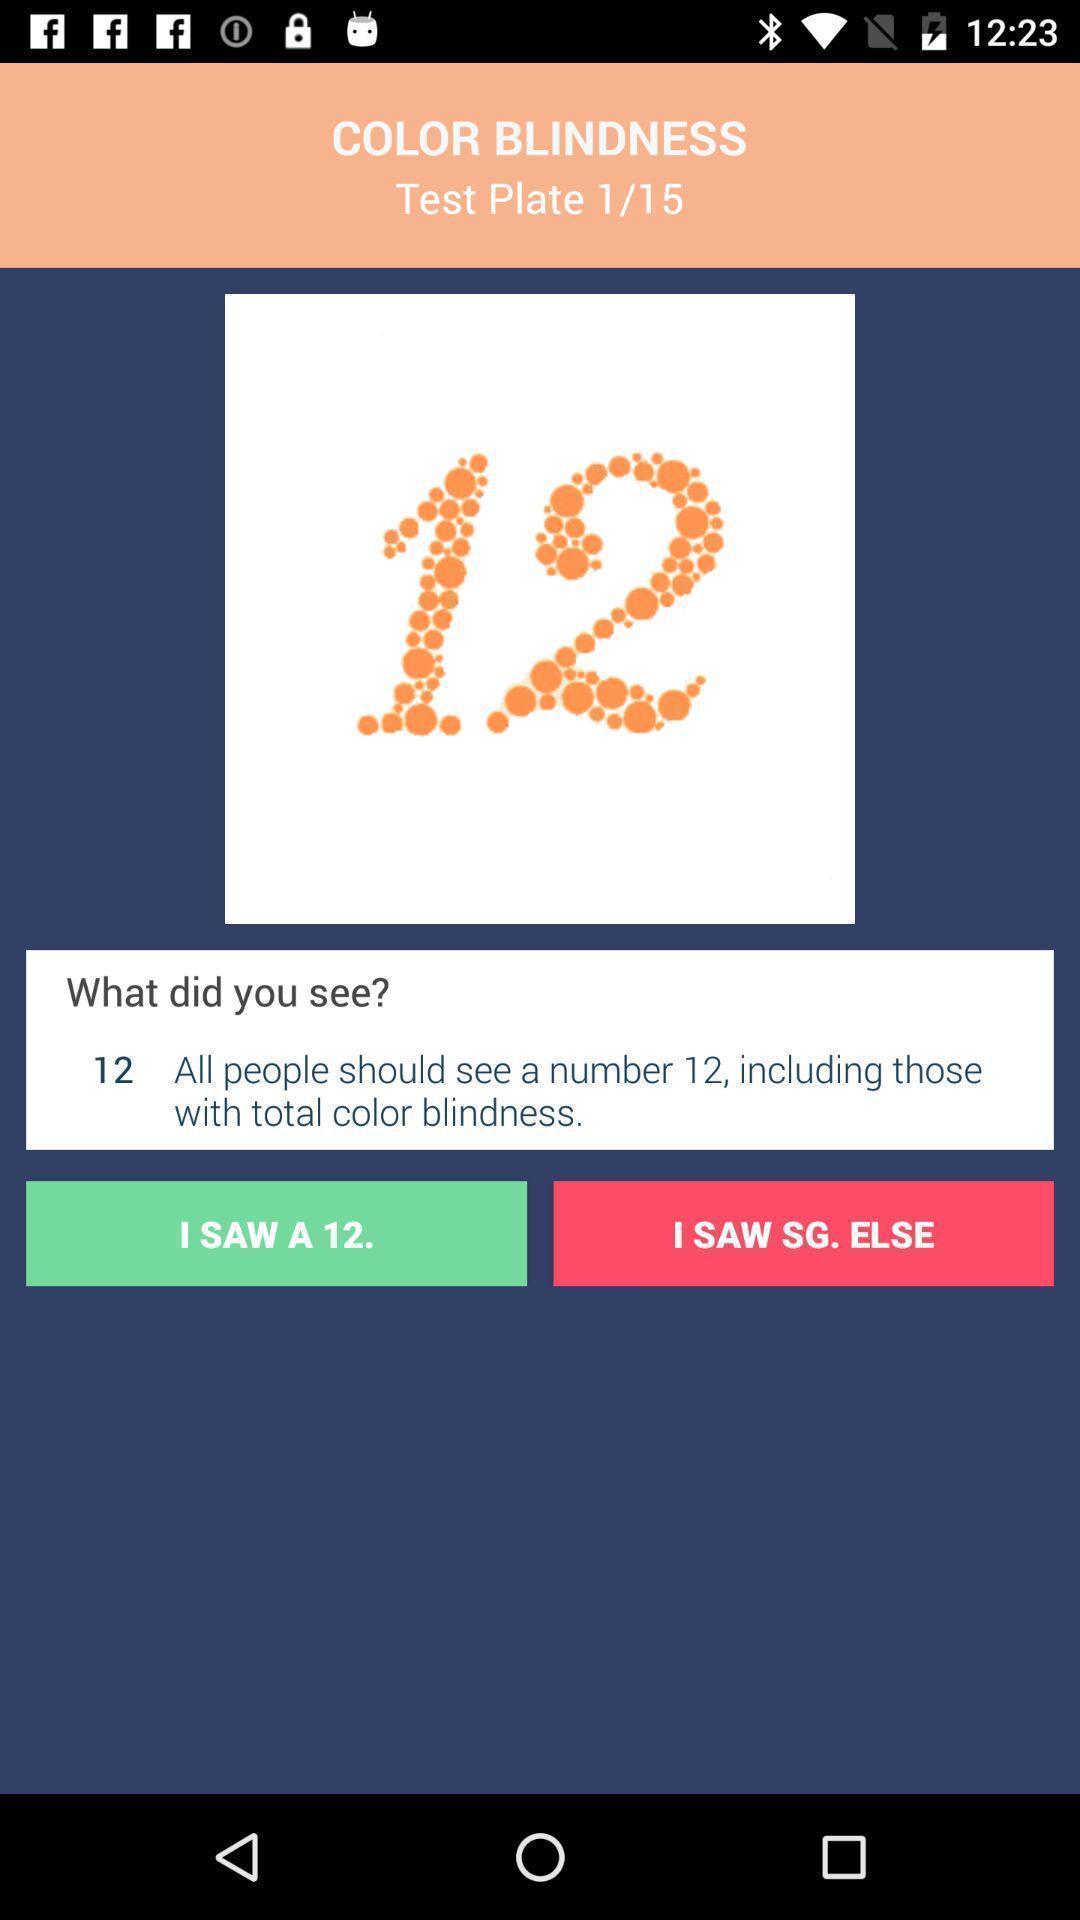Tell me what you see in this picture. Window displaying an app for eye testing. 